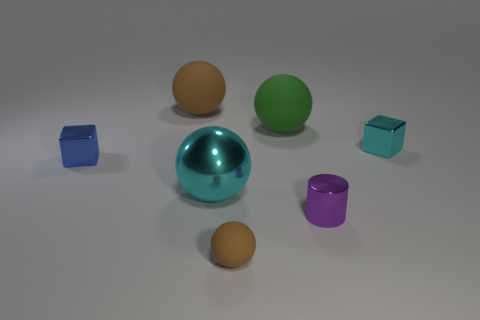Can you determine the light source direction in the image? Yes, the direction of the light source in the image can be inferred by the shadows cast by the objects. The shadows are oriented towards the lower right of the image, which suggests that the light source is coming from the upper left side of the scene. Is there anything in the image that suggests motion or stillness? The image captures a moment of stillness; there are no indications of motion, such as blurring or displacement of objects. All the shadows are crisp, and there are no signs of kinetic energy, suggesting the objects are stationary. 